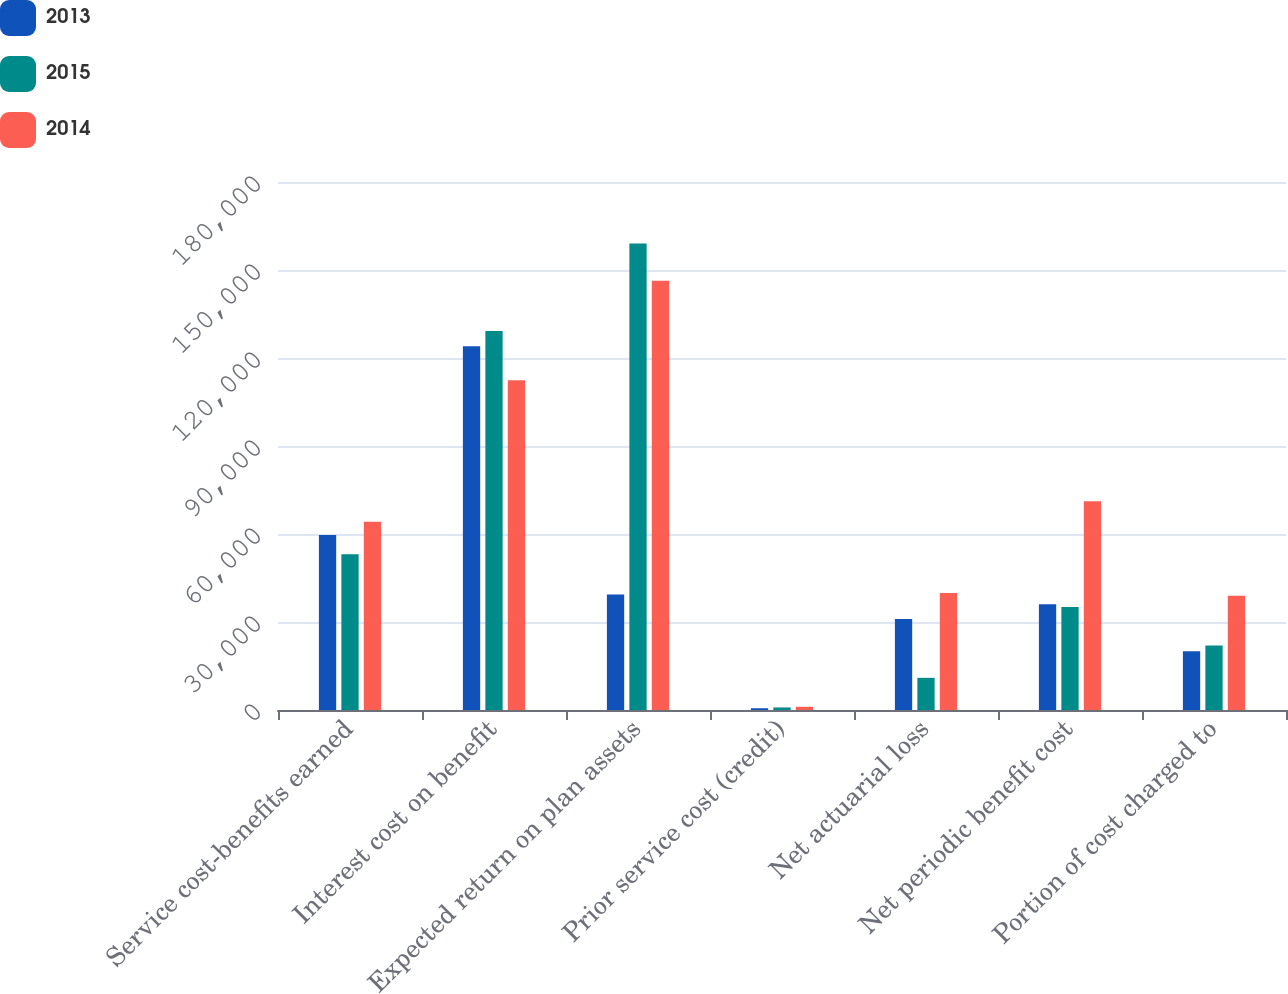Convert chart to OTSL. <chart><loc_0><loc_0><loc_500><loc_500><stacked_bar_chart><ecel><fcel>Service cost-benefits earned<fcel>Interest cost on benefit<fcel>Expected return on plan assets<fcel>Prior service cost (credit)<fcel>Net actuarial loss<fcel>Net periodic benefit cost<fcel>Portion of cost charged to<nl><fcel>2013<fcel>59627<fcel>123983<fcel>39410<fcel>594<fcel>31056<fcel>36029<fcel>20036<nl><fcel>2015<fcel>53080<fcel>129194<fcel>158998<fcel>869<fcel>10963<fcel>35108<fcel>21985<nl><fcel>2014<fcel>64195<fcel>112392<fcel>146333<fcel>1097<fcel>39852<fcel>71203<fcel>38968<nl></chart> 